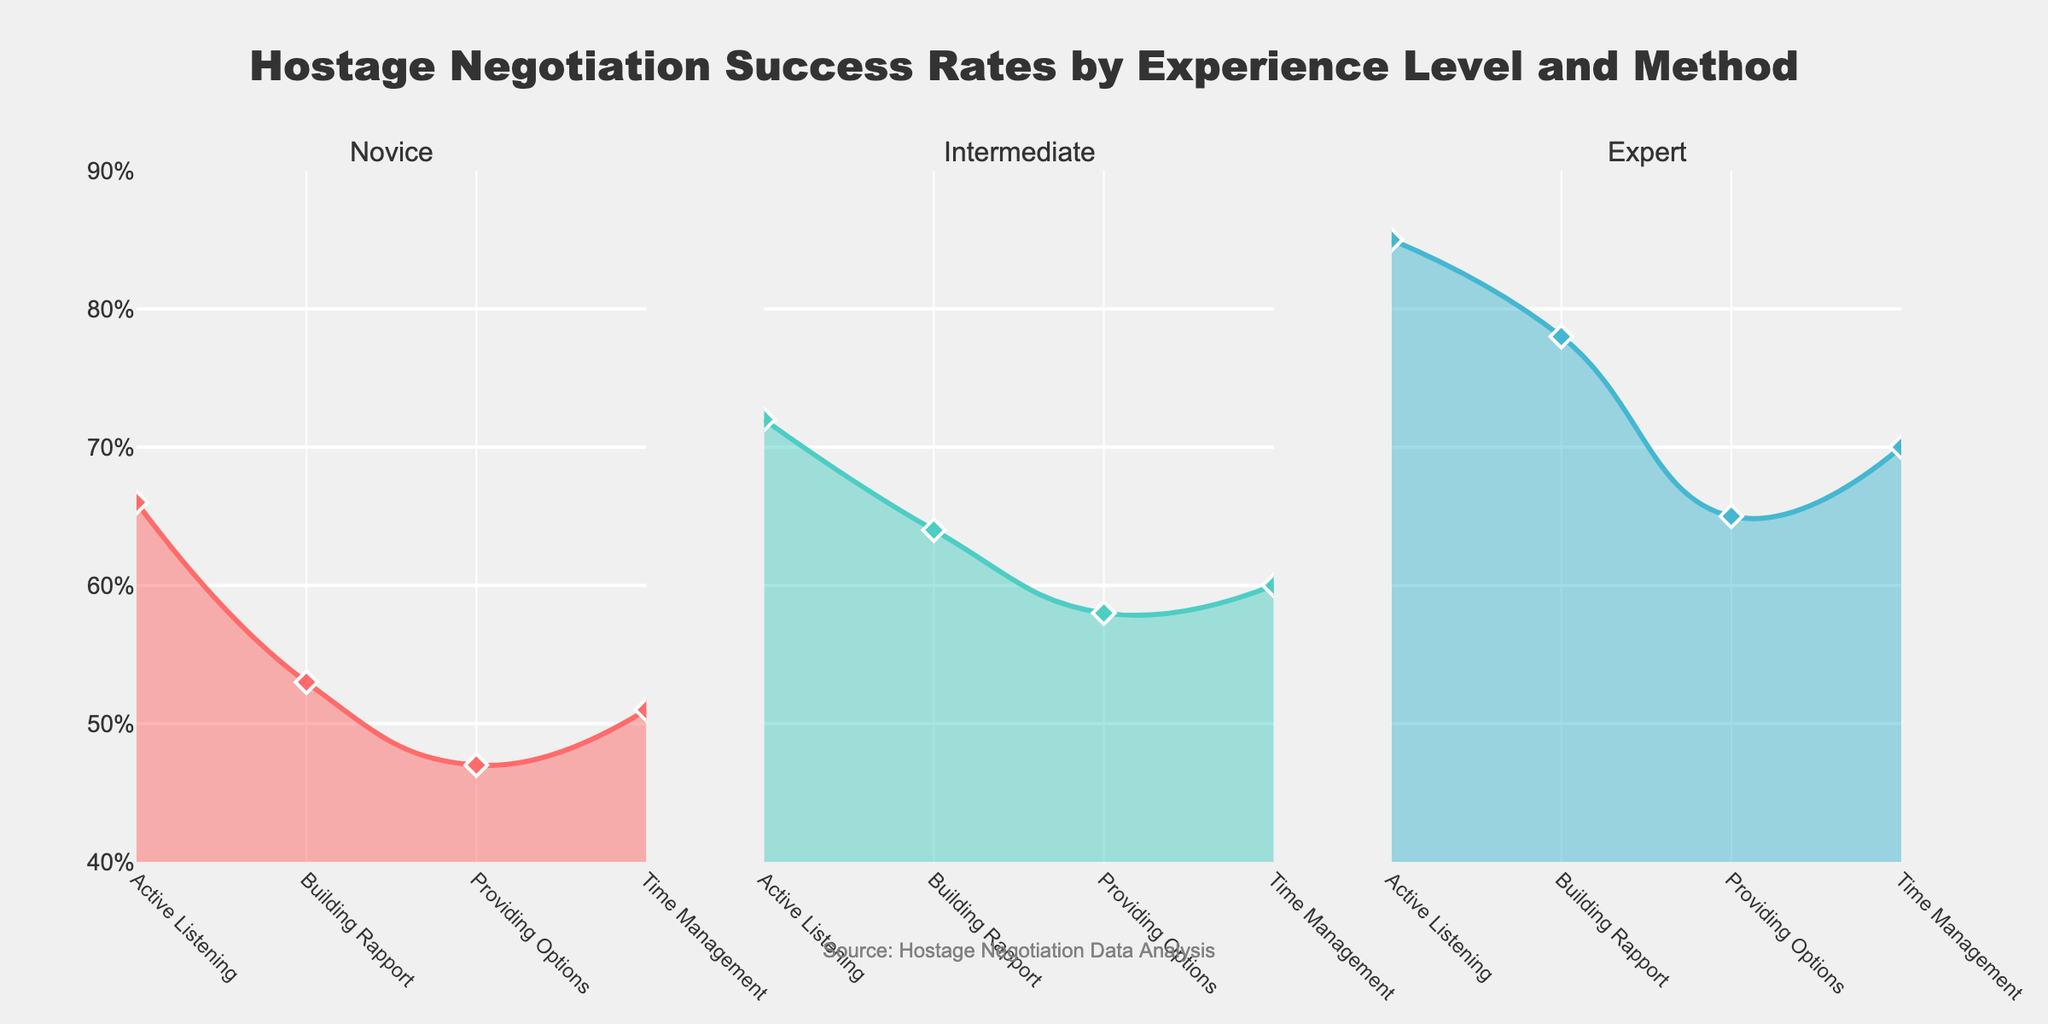How many unique negotiation methods are represented in the chart? Count the number of distinct methods listed on the x-axis of any subplot. There are four methods: Active Listening, Building Rapport, Providing Options, and Time Management.
Answer: 4 Which experience level shows the highest success rate for the method 'Active Listening'? Compare the success rates for 'Active Listening' across the three experience levels. The Expert level has the highest success rate for 'Active Listening' at 0.85.
Answer: Expert What is the difference in success rates for 'Building Rapport' between Novice and Expert negotiators? Subtract the success rate of Novice (0.53) from that of Expert (0.78) for 'Building Rapport'. The difference is 0.78 - 0.53 = 0.25.
Answer: 0.25 What is the average success rate for Intermediate negotiators across all methods? Add up the success rates for Intermediate negotiators (0.72, 0.64, 0.58, 0.60) and divide by the number of methods, which is 4. The average is (0.72 + 0.64 + 0.58 + 0.60) / 4 = 0.635.
Answer: 0.635 Which negotiation method shows the least improvement in success rate from Novice to Expert experience levels? Calculate the difference in success rates between Expert and Novice levels for each method, then identify the smallest increase. The differences are: Active Listening (0.19), Building Rapport (0.25), Providing Options (0.18), Time Management (0.19). The smallest increase is for Providing Options (0.18).
Answer: Providing Options In which subplot does the method 'Time Management' have the highest success rate? Look at the success rates for 'Time Management' in each of the three subplots. The Expert level subplot shows the highest success rate for 'Time Management' at 0.70.
Answer: Expert What is the range of success rates for all methods in the Novice experience level? Identify the highest and lowest success rates for the Novice level, then subtract the lowest from the highest. For Novice: Highest (0.66, Active Listening), Lowest (0.47, Providing Options). The range is 0.66 - 0.47 = 0.19.
Answer: 0.19 Between 'Active Listening' and 'Providing Options', which method has a bigger gap in success rate between Intermediate and Novice negotiators? Calculate the difference in success rates between Intermediate and Novice for both methods, then compare. Active Listening: 0.72 - 0.66 = 0.06. Providing Options: 0.58 - 0.47 = 0.11. The bigger gap is for Providing Options.
Answer: Providing Options Which combination of experience level and method yields the lowest success rate? Check each subplot and each method to find the lowest rate. The lowest success rate is for Novice negotiators using Providing Options, which is 0.47.
Answer: Novice, Providing Options 